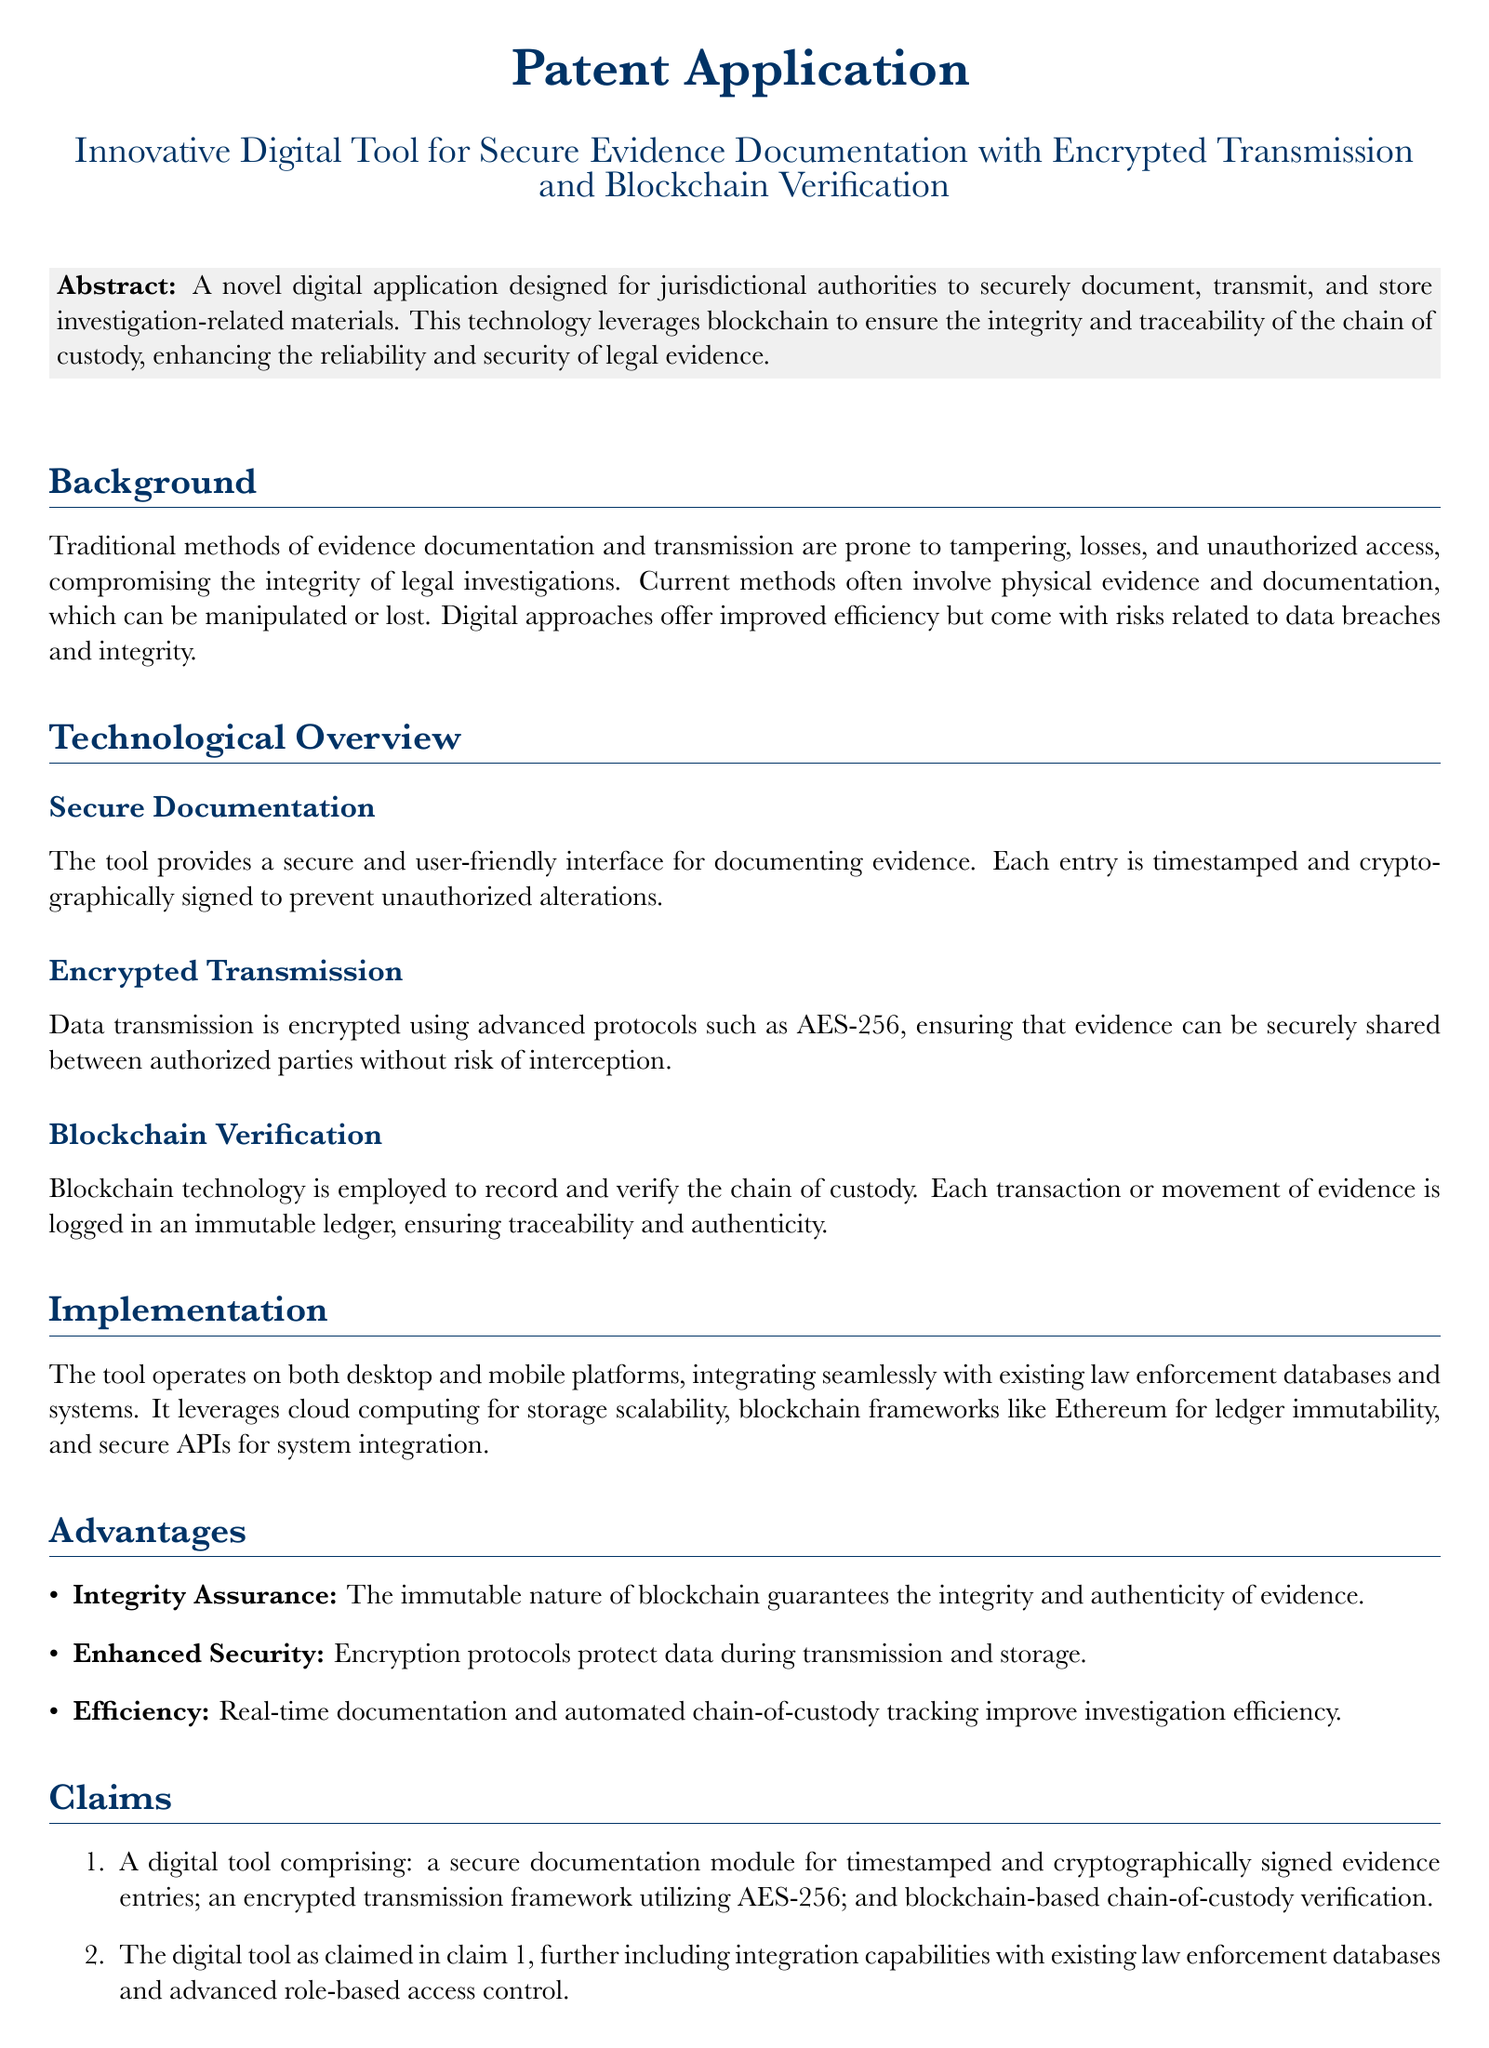What is the title of the patent application? The title is prominently displayed at the beginning of the document, indicating the specific focus of the patent application.
Answer: Innovative Digital Tool for Secure Evidence Documentation with Encrypted Transmission and Blockchain Verification What technology does the application utilize to ensure integrity? The document mentions that the application employs a specific technology known for its effectiveness in ensuring data integrity and traceability.
Answer: Blockchain What is the primary encryption protocol used for data transmission? The technological overview section specifies the advanced encryption standard utilized for secure data transfer within the tool.
Answer: AES-256 What does the tool provide for documenting evidence? The background section indicates the functionality of the tool in relation to evidence documentation.
Answer: Secure and user-friendly interface What advantage does the blockchain technology provide according to the document? The advantages section outlines the benefits associated with utilizing blockchain technology in the context of evidence handling.
Answer: Integrity Assurance What platforms is the tool designed to operate on? The implementation section of the document identifies where the tool can be utilized effectively.
Answer: Desktop and mobile platforms What is the purpose of the cryptographic signing of evidence entries? The technological overview provides clarity on the role of cryptographic measures in protecting evidence documentation.
Answer: Prevent unauthorized alterations How many claims are presented in the document? The claims section specifies the number of distinct claims that outline the tool's features and capabilities.
Answer: Two 